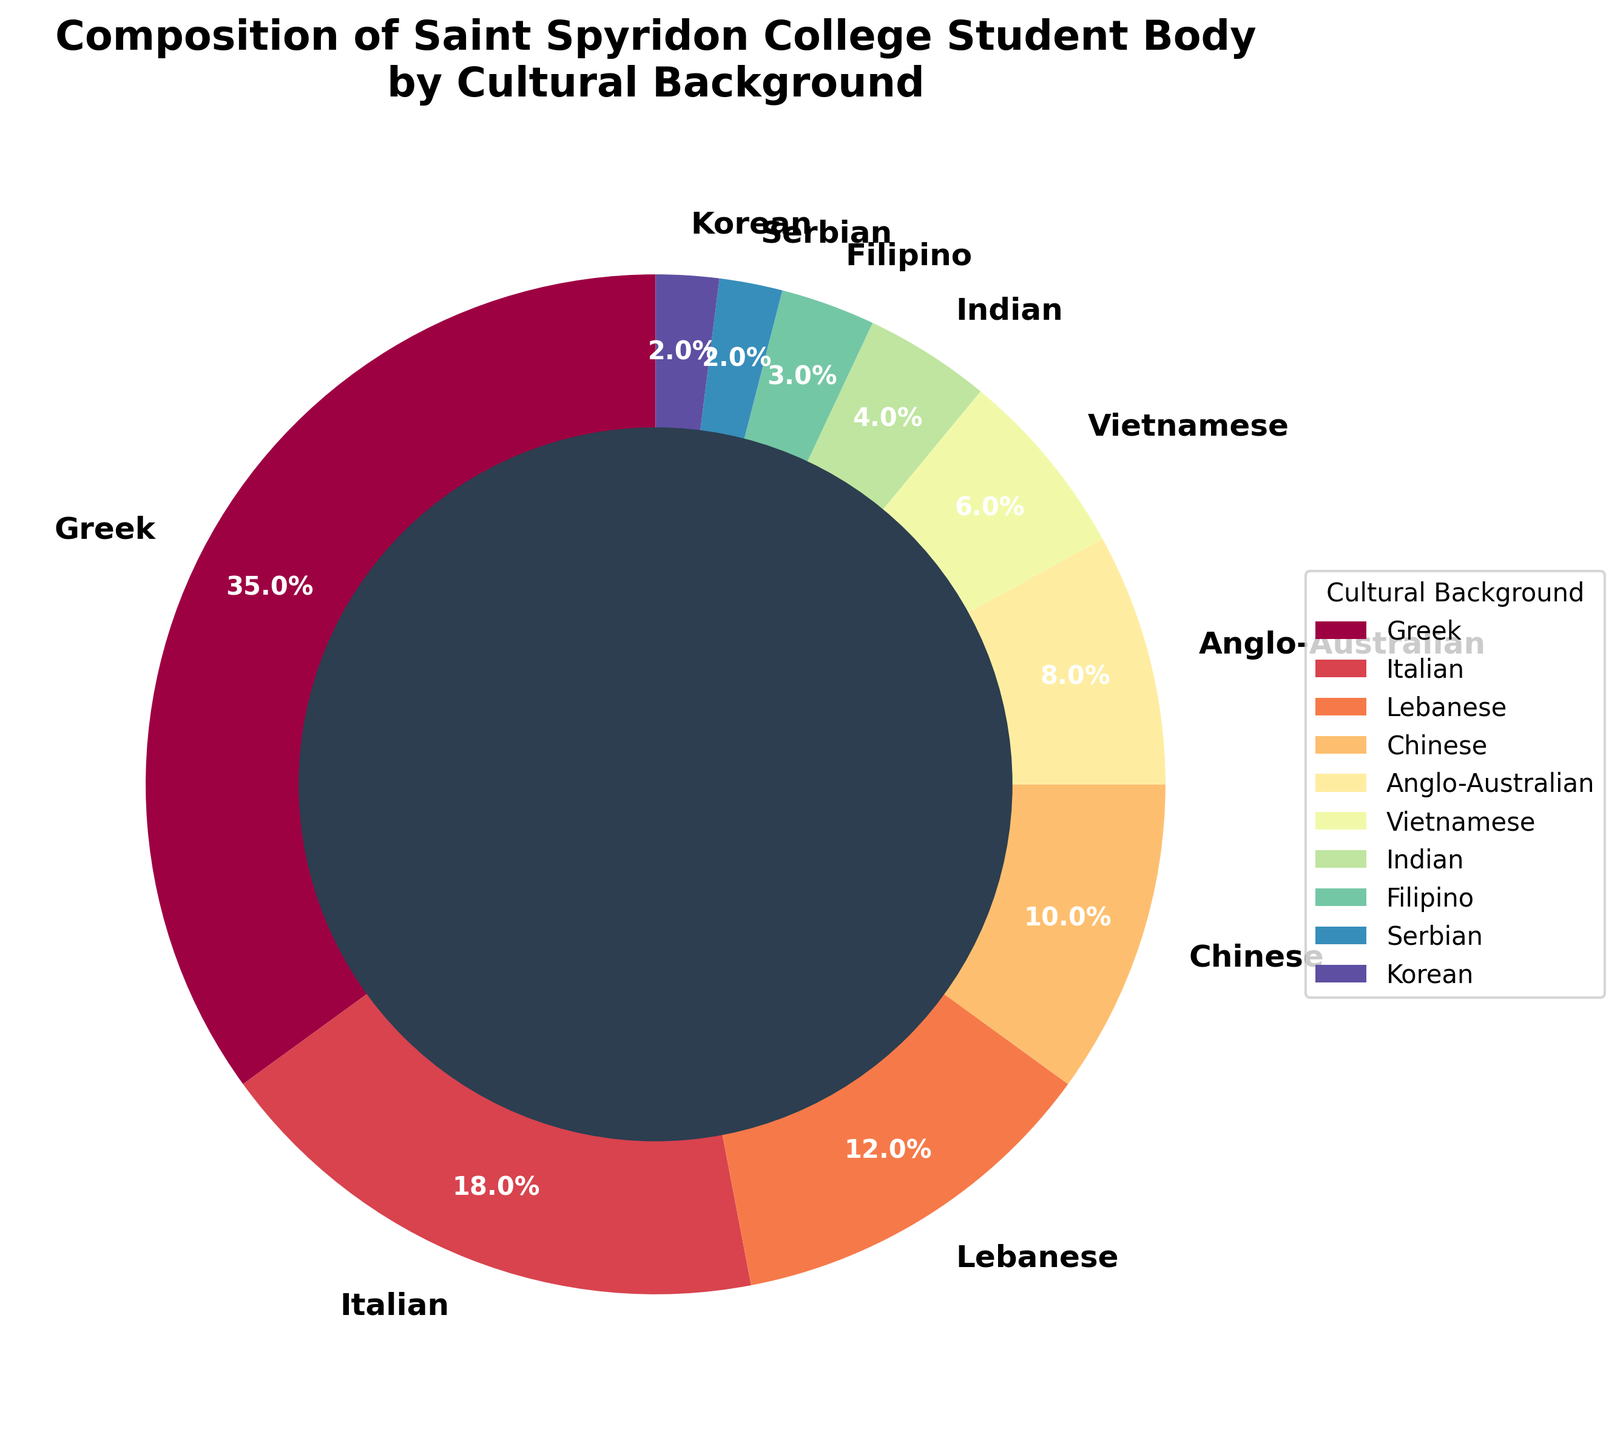what is the total percentage of students from Greek and Italian backgrounds? To find the total percentage of students from Greek and Italian backgrounds, you need to add the percentage of Greek students (35%) and Italian students (18%). So, 35% + 18% = 53%
Answer: 53% Which cultural background has the lowest representation in the student body? By looking at the smallest percentage on the pie chart, we can see that Serbian and Korean backgrounds both have the lowest representation, each with 2%.
Answer: Serbian and Korean How many cultural backgrounds have a representation of more than 10%? From the chart, we observe the percentages and identify the cultural backgrounds greater than 10%: Greek (35%), Italian (18%), and Lebanese (12%). There are a total of 3 cultural backgrounds.
Answer: 3 Which group has a larger representation: Chinese or Anglo-Australian? By looking at the chart, the Chinese group has a representation of 10%, and Anglo-Australian has 8%. So, the Chinese group has a larger representation.
Answer: Chinese How many cultural backgrounds make up less than 5%? We look at the pie chart and identify the categories with less than 5% representation: Indian (4%), Filipino (3%), Serbian (2%), and Korean (2%). There are 4 cultural backgrounds in total.
Answer: 4 What is the combined percentage of Vietnamese and Indian students? To find the combined percentage, add the percentages of Vietnamese (6%) and Indian (4%). So, 6% + 4% = 10%
Answer: 10% Is the percentage of Lebanese students greater than double the percentage of Vietnamese students? The percentage of Lebanese students is 12%, and double the percentage of Vietnamese students would be 2 * 6% = 12%. Since 12% is equal to 12%, the percentage of Lebanese students is not greater than double the Vietnamese percentage; it is exactly equal.
Answer: No Which cultural background has the second-largest representation, and what is its percentage? The chart shows that the second-largest representation is Italian with 18%, following Greek which is the largest at 35%.
Answer: Italian, 18% What is the difference in percentage between Filipino and Indian students? To find the difference, subtract the percentage of Indian students (4%) from Filipino students (3%). So, 3% - 4% = -1%. The absolute value is 1%.
Answer: 1% What is the total percentage of students not included in the top three cultural backgrounds? The top three cultural backgrounds are Greek (35%), Italian (18%), and Lebanese (12%), summing to 35% + 18% + 12% = 65%. Subtracting from 100% gives the total percentage of students not in the top three: 100% - 65% = 35%.
Answer: 35% 